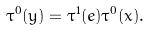<formula> <loc_0><loc_0><loc_500><loc_500>\tau ^ { 0 } ( y ) = \tau ^ { 1 } ( e ) \tau ^ { 0 } ( x ) .</formula> 